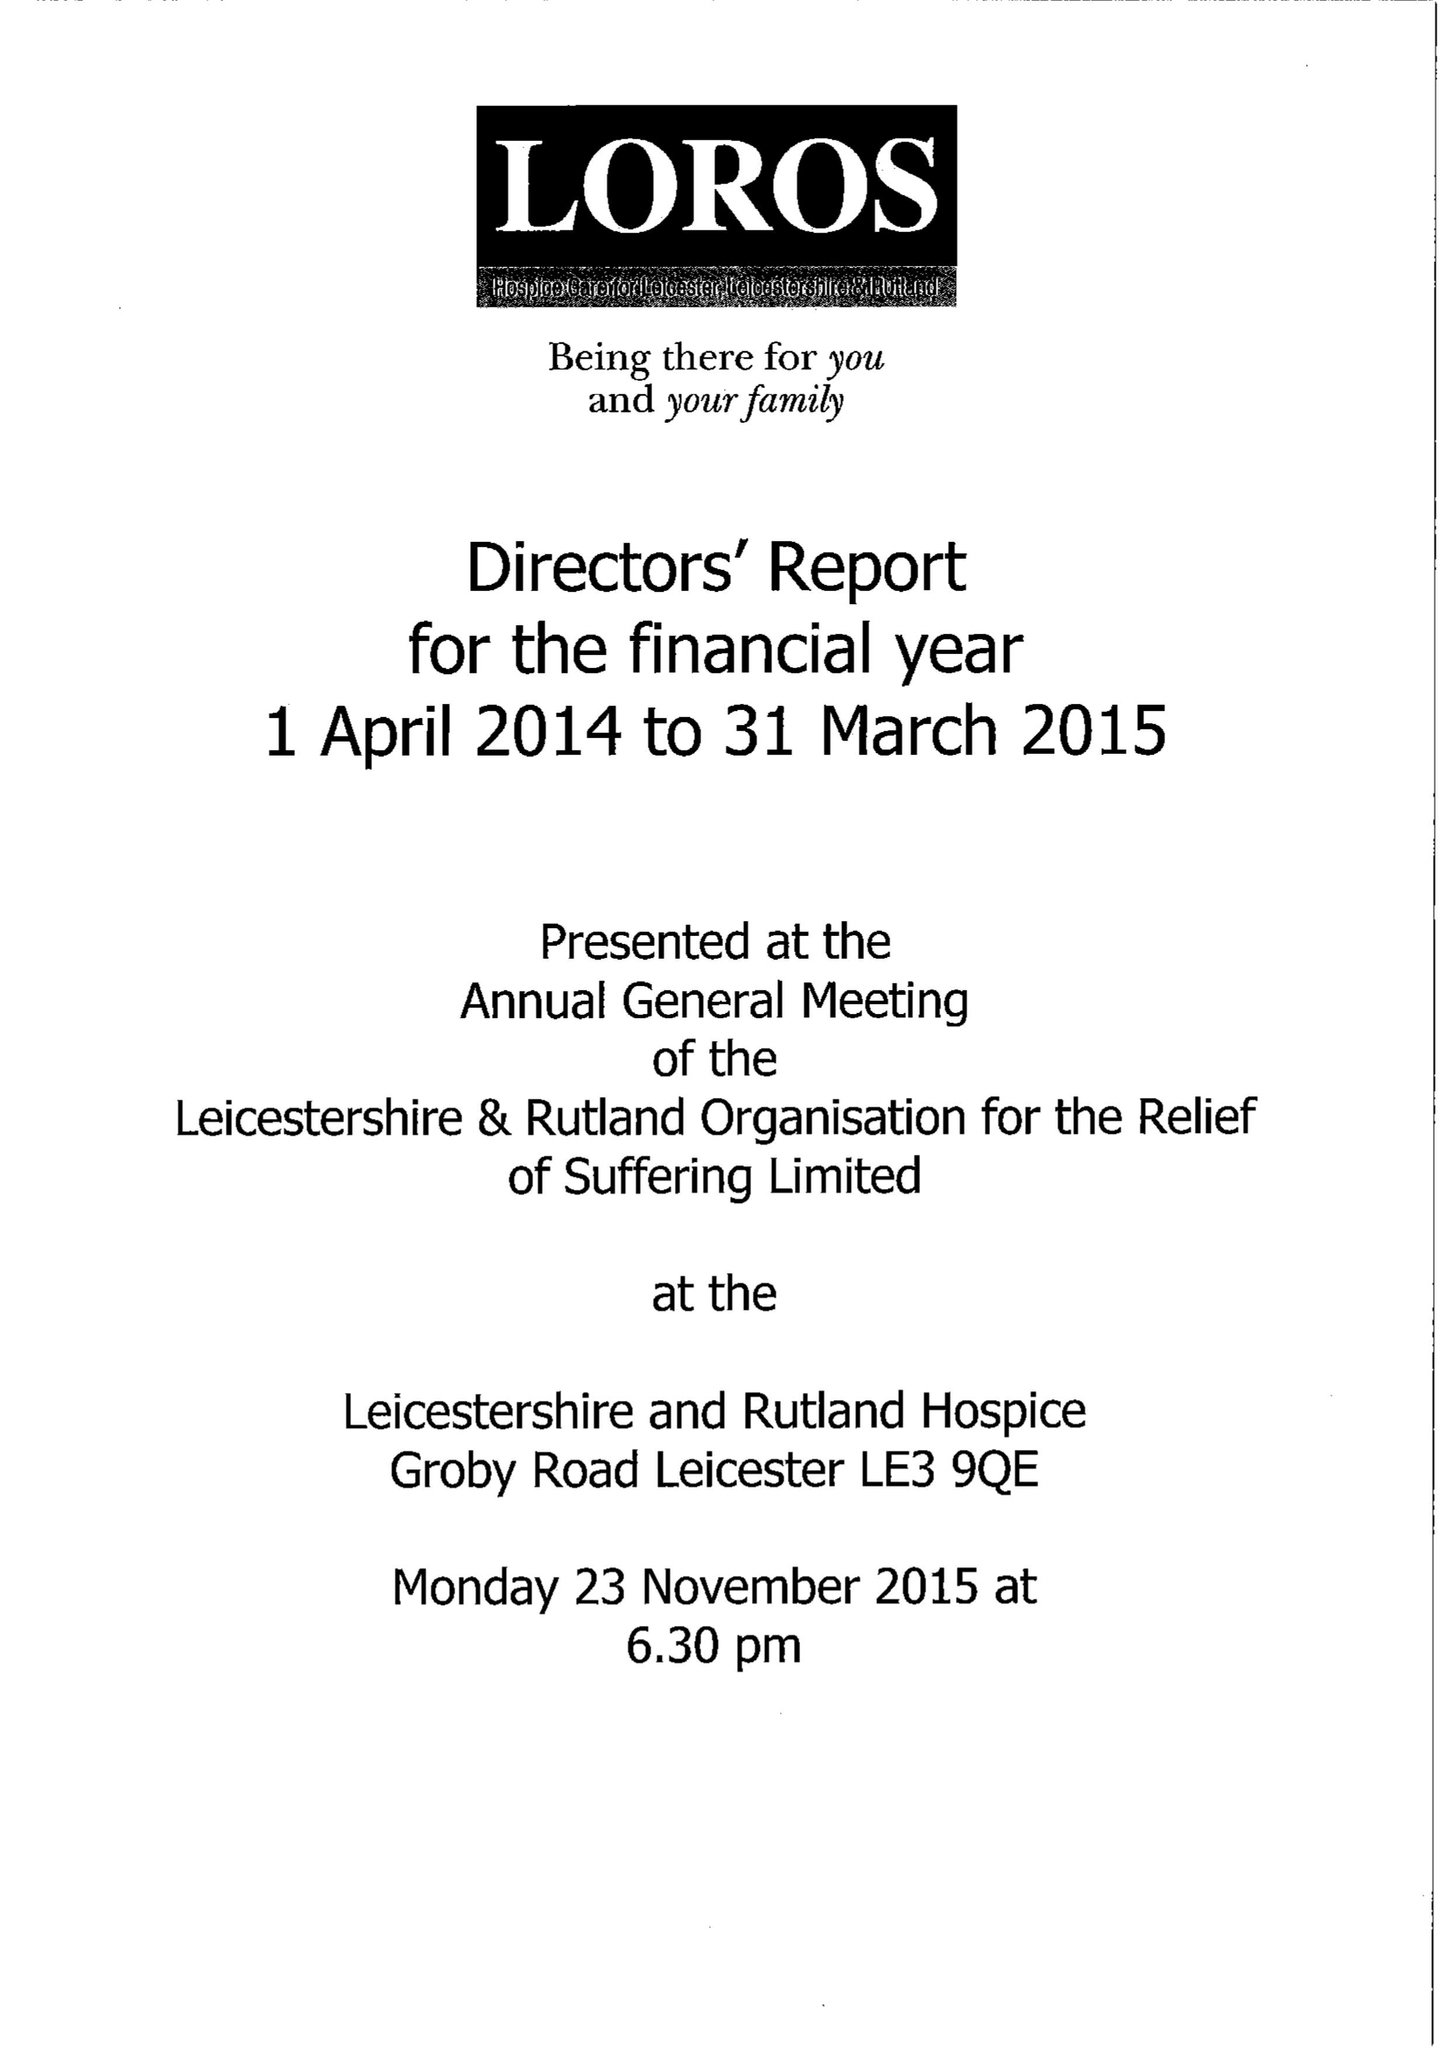What is the value for the spending_annually_in_british_pounds?
Answer the question using a single word or phrase. 11452781.00 